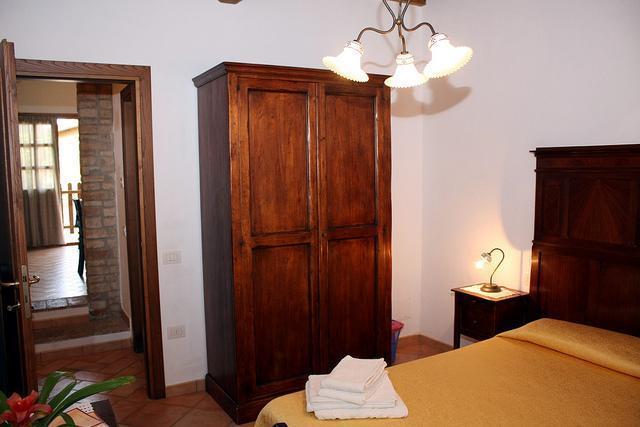How many lamps are pictured?
Give a very brief answer. 1. How many beds are visible?
Give a very brief answer. 1. 